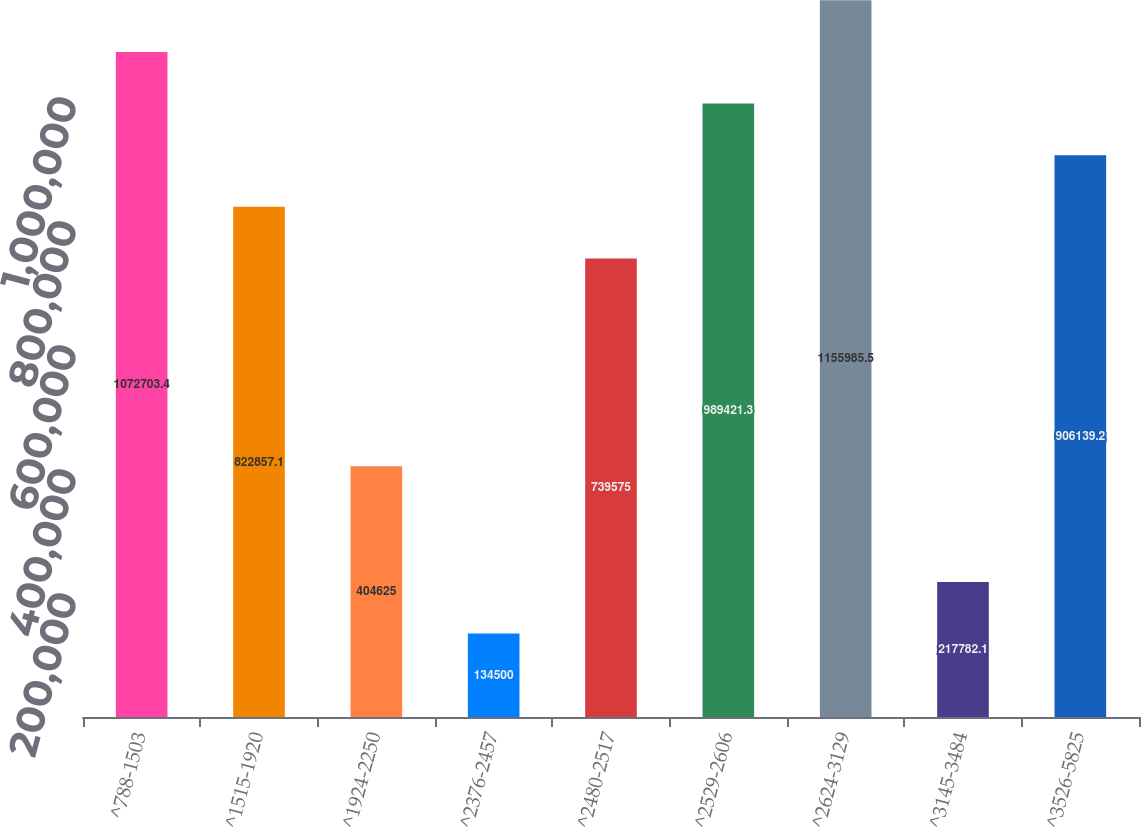<chart> <loc_0><loc_0><loc_500><loc_500><bar_chart><fcel>^788-1503<fcel>^1515-1920<fcel>^1924-2250<fcel>^2376-2457<fcel>^2480-2517<fcel>^2529-2606<fcel>^2624-3129<fcel>^3145-3484<fcel>^3526-5825<nl><fcel>1.0727e+06<fcel>822857<fcel>404625<fcel>134500<fcel>739575<fcel>989421<fcel>1.15599e+06<fcel>217782<fcel>906139<nl></chart> 